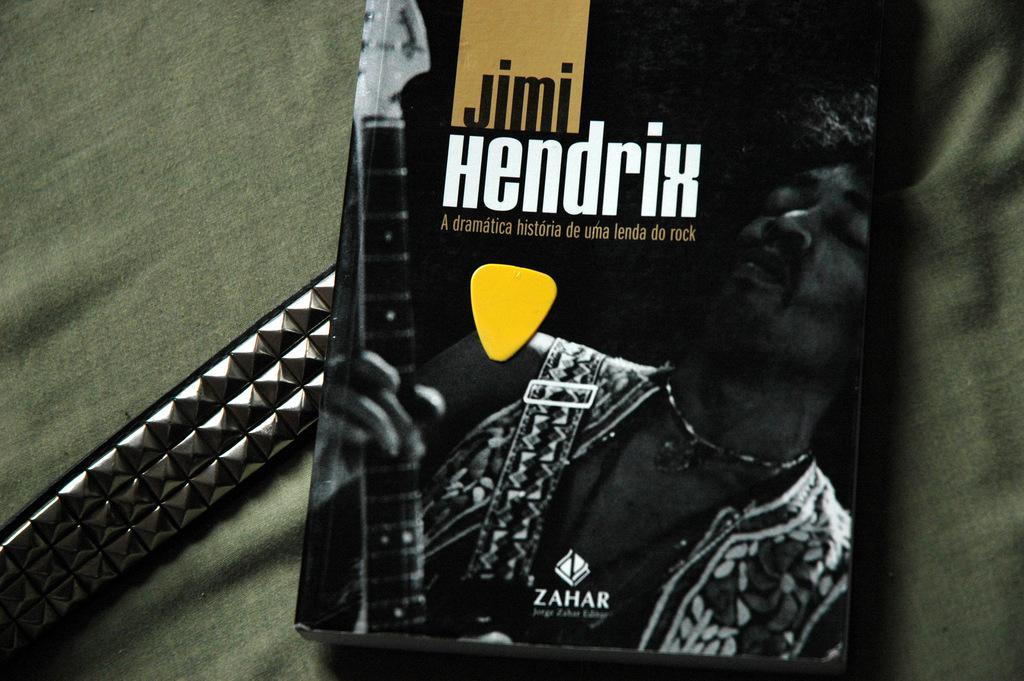<image>
Provide a brief description of the given image. A book about Jimi Hendrix has a yellow guitar pick on it. 